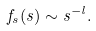Convert formula to latex. <formula><loc_0><loc_0><loc_500><loc_500>f _ { s } ( s ) \sim s ^ { - l } .</formula> 